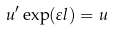Convert formula to latex. <formula><loc_0><loc_0><loc_500><loc_500>u ^ { \prime } \exp ( \varepsilon l ) = u</formula> 